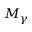Convert formula to latex. <formula><loc_0><loc_0><loc_500><loc_500>M _ { \gamma }</formula> 